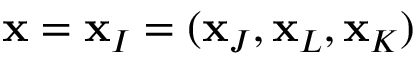<formula> <loc_0><loc_0><loc_500><loc_500>x = x _ { I } = ( x _ { J } , x _ { L } , x _ { K } )</formula> 